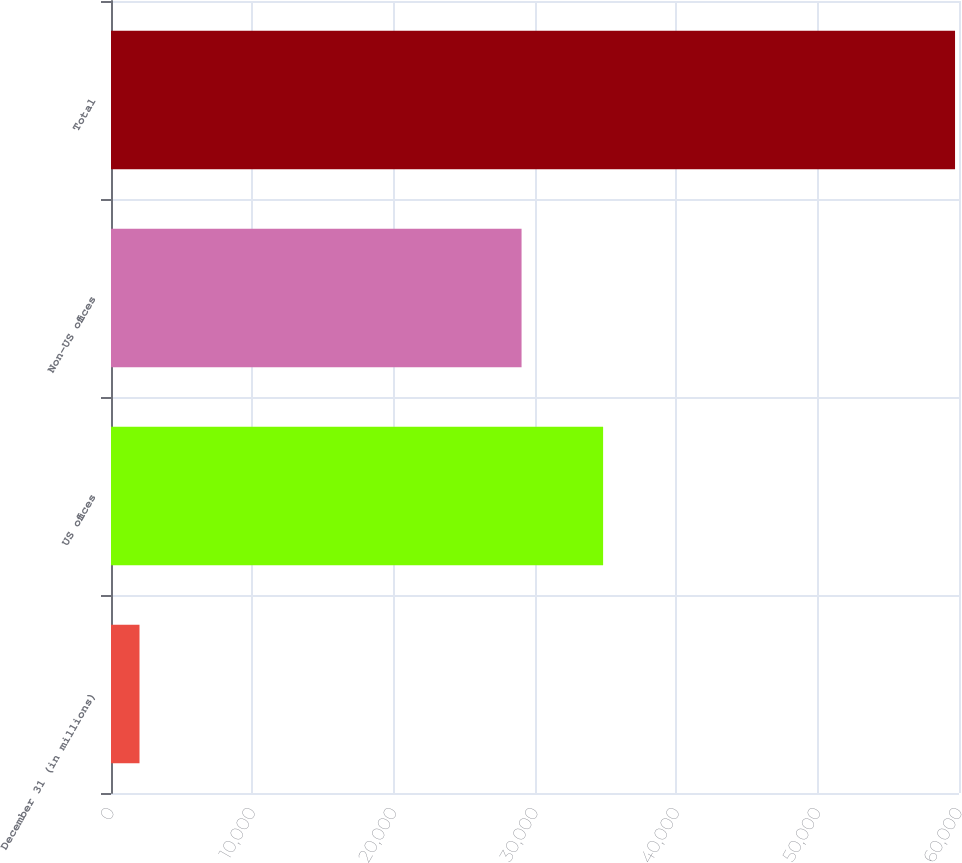<chart> <loc_0><loc_0><loc_500><loc_500><bar_chart><fcel>December 31 (in millions)<fcel>US offices<fcel>Non-US offices<fcel>Total<nl><fcel>2017<fcel>34819.3<fcel>29049<fcel>59720<nl></chart> 